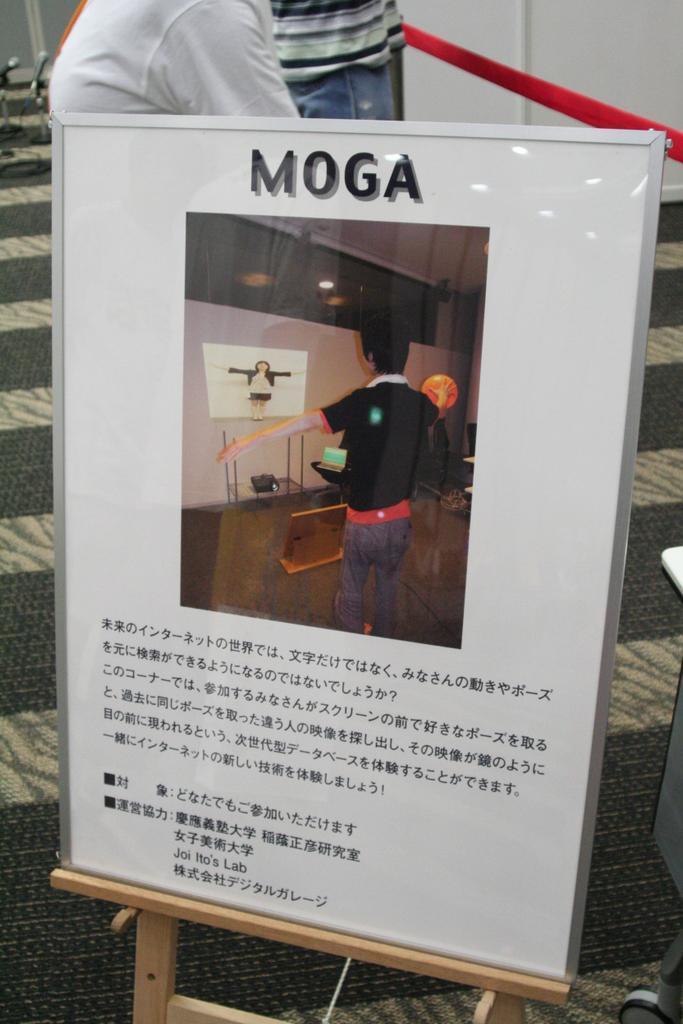Describe this image in one or two sentences. This looks like a board with a picture and letter on it. I can see two people standing. This looks like a thread, which is red in color. I think this is the carpet on the floor. 